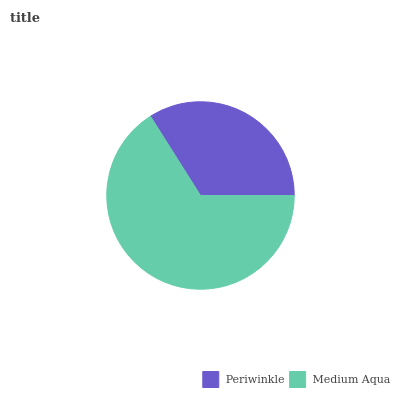Is Periwinkle the minimum?
Answer yes or no. Yes. Is Medium Aqua the maximum?
Answer yes or no. Yes. Is Medium Aqua the minimum?
Answer yes or no. No. Is Medium Aqua greater than Periwinkle?
Answer yes or no. Yes. Is Periwinkle less than Medium Aqua?
Answer yes or no. Yes. Is Periwinkle greater than Medium Aqua?
Answer yes or no. No. Is Medium Aqua less than Periwinkle?
Answer yes or no. No. Is Medium Aqua the high median?
Answer yes or no. Yes. Is Periwinkle the low median?
Answer yes or no. Yes. Is Periwinkle the high median?
Answer yes or no. No. Is Medium Aqua the low median?
Answer yes or no. No. 